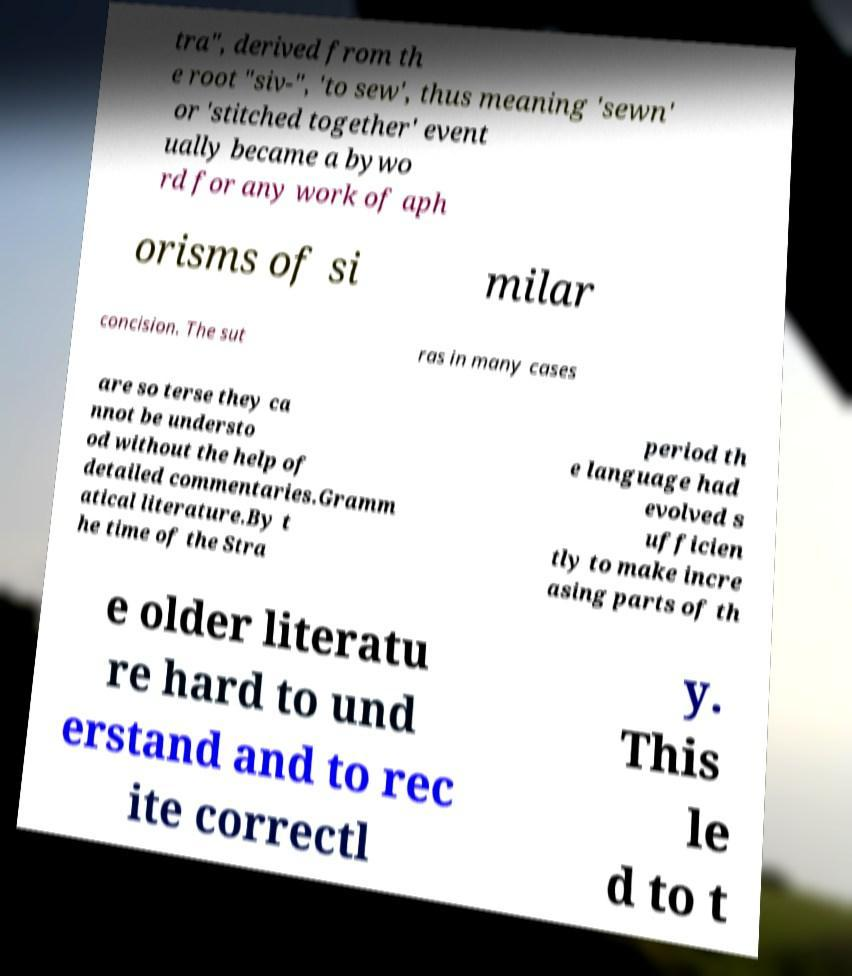There's text embedded in this image that I need extracted. Can you transcribe it verbatim? tra", derived from th e root "siv-", 'to sew', thus meaning 'sewn' or 'stitched together' event ually became a bywo rd for any work of aph orisms of si milar concision. The sut ras in many cases are so terse they ca nnot be understo od without the help of detailed commentaries.Gramm atical literature.By t he time of the Stra period th e language had evolved s ufficien tly to make incre asing parts of th e older literatu re hard to und erstand and to rec ite correctl y. This le d to t 